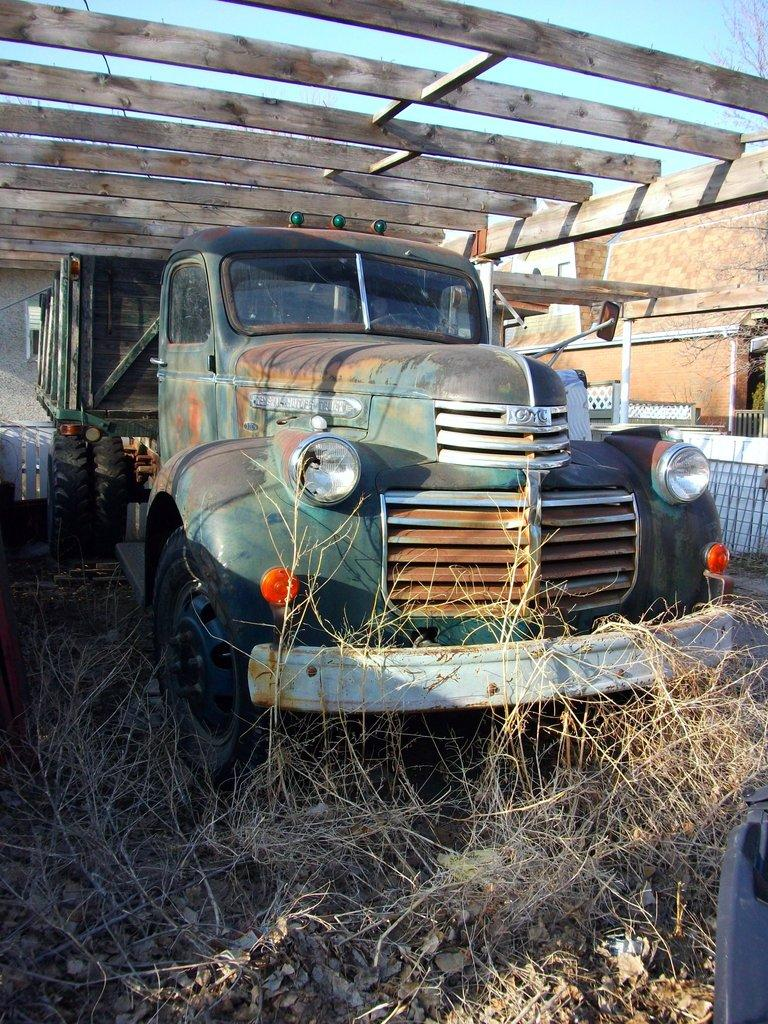What is the main subject in the center of the image? There is a vehicle in the center of the image. What is the position of the vehicle in the image? The vehicle is on the ground. What type of natural elements can be seen at the bottom of the image? Leaves and plants are visible at the bottom of the image. What architectural features are present in the background of the image? There are wooden bars and a wall in the background of the image. What type of vegetation is visible in the background of the image? There is a tree in the background of the image. What part of the natural environment is visible in the background of the image? The sky is visible in the background of the image. What type of cook is visible in the image? There is no cook present in the image. What type of laborer can be seen working on the wooden bars in the background? There is no laborer present in the image; the wooden bars are just a background element. 